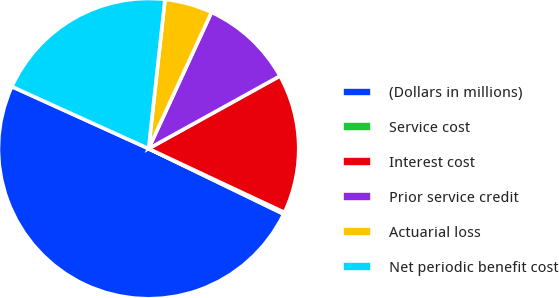Convert chart to OTSL. <chart><loc_0><loc_0><loc_500><loc_500><pie_chart><fcel>(Dollars in millions)<fcel>Service cost<fcel>Interest cost<fcel>Prior service credit<fcel>Actuarial loss<fcel>Net periodic benefit cost<nl><fcel>49.6%<fcel>0.2%<fcel>15.02%<fcel>10.08%<fcel>5.14%<fcel>19.96%<nl></chart> 